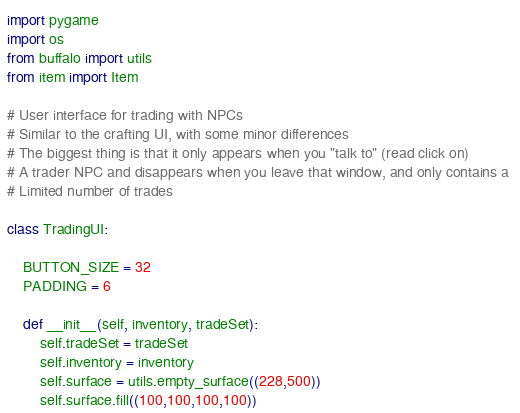<code> <loc_0><loc_0><loc_500><loc_500><_Python_>import pygame
import os
from buffalo import utils
from item import Item

# User interface for trading with NPCs
# Similar to the crafting UI, with some minor differences
# The biggest thing is that it only appears when you "talk to" (read click on)
# A trader NPC and disappears when you leave that window, and only contains a 
# Limited number of trades

class TradingUI:

	BUTTON_SIZE = 32
	PADDING = 6

	def __init__(self, inventory, tradeSet):
		self.tradeSet = tradeSet
		self.inventory = inventory
		self.surface = utils.empty_surface((228,500))
		self.surface.fill((100,100,100,100))</code> 